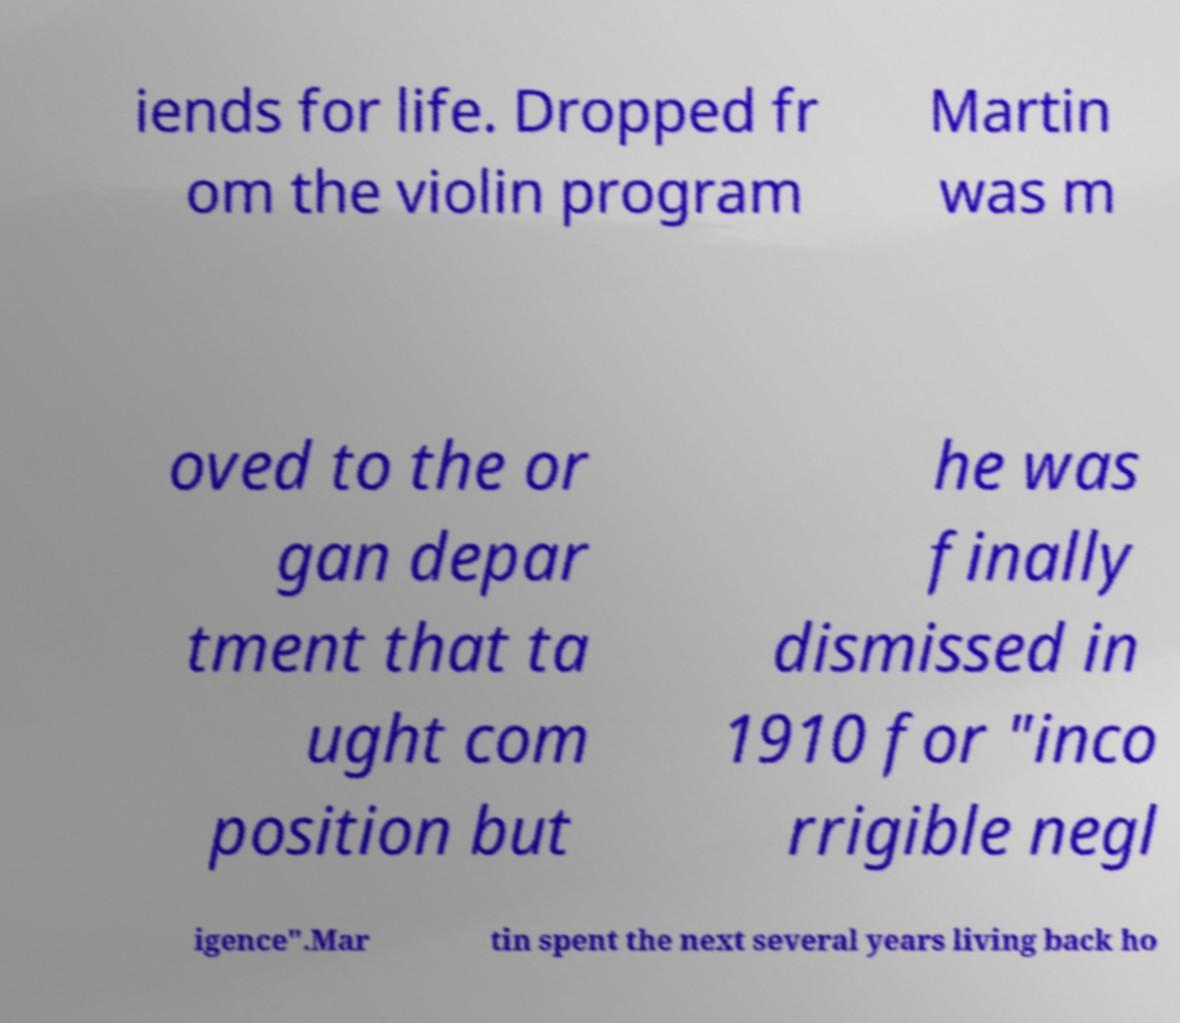For documentation purposes, I need the text within this image transcribed. Could you provide that? iends for life. Dropped fr om the violin program Martin was m oved to the or gan depar tment that ta ught com position but he was finally dismissed in 1910 for "inco rrigible negl igence".Mar tin spent the next several years living back ho 